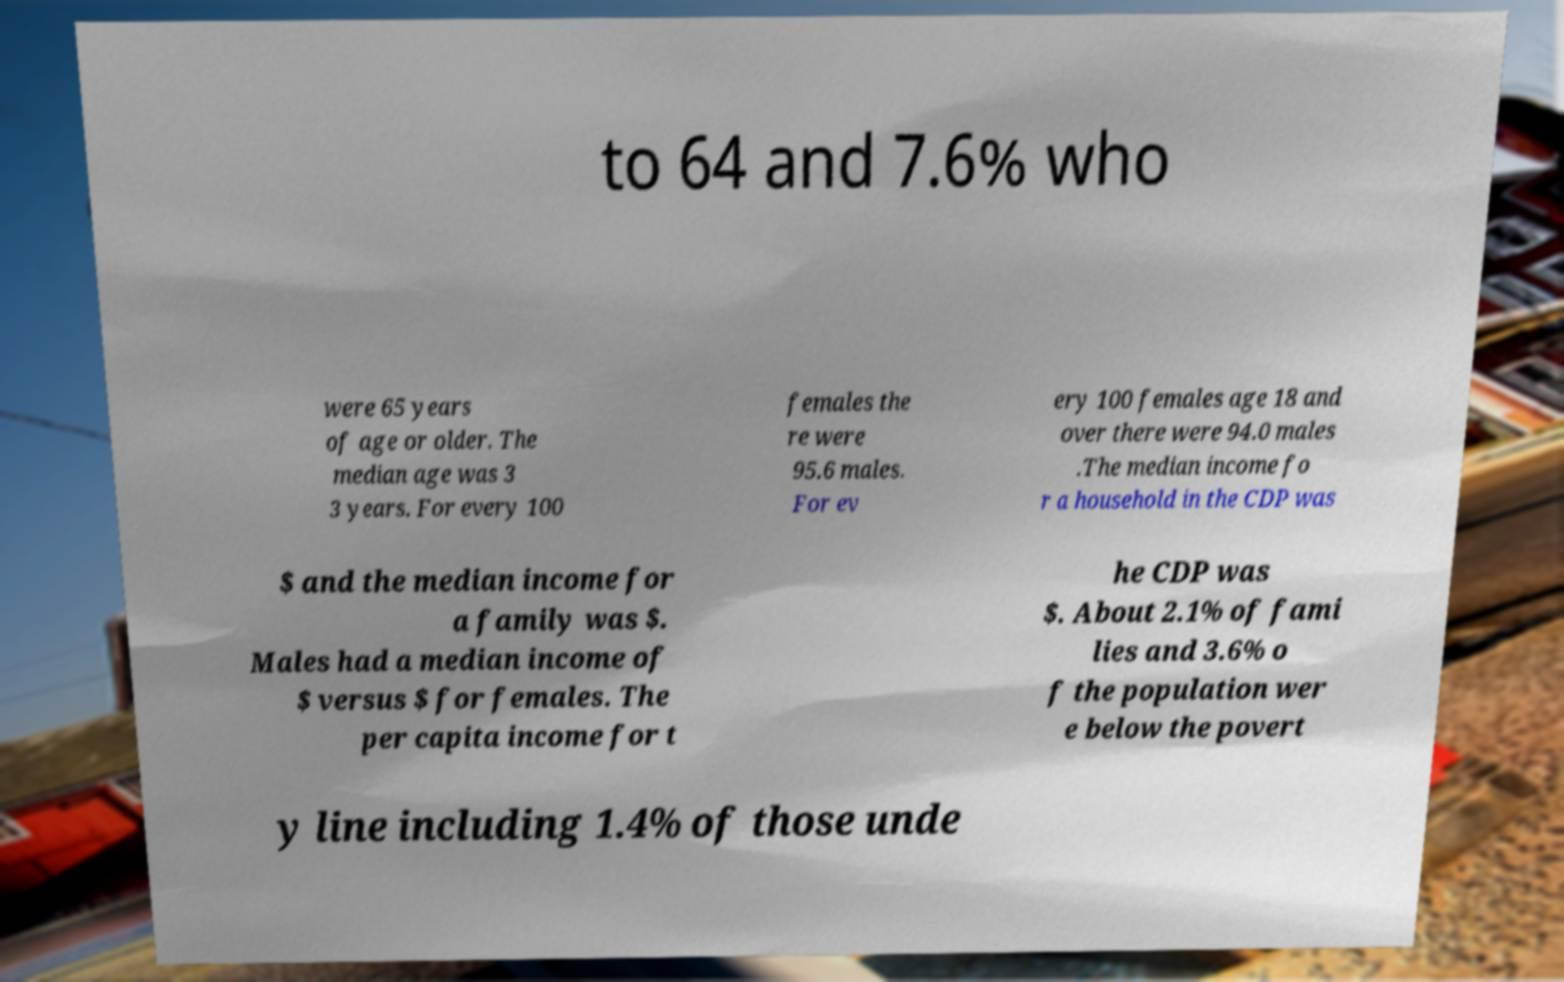Please identify and transcribe the text found in this image. to 64 and 7.6% who were 65 years of age or older. The median age was 3 3 years. For every 100 females the re were 95.6 males. For ev ery 100 females age 18 and over there were 94.0 males .The median income fo r a household in the CDP was $ and the median income for a family was $. Males had a median income of $ versus $ for females. The per capita income for t he CDP was $. About 2.1% of fami lies and 3.6% o f the population wer e below the povert y line including 1.4% of those unde 